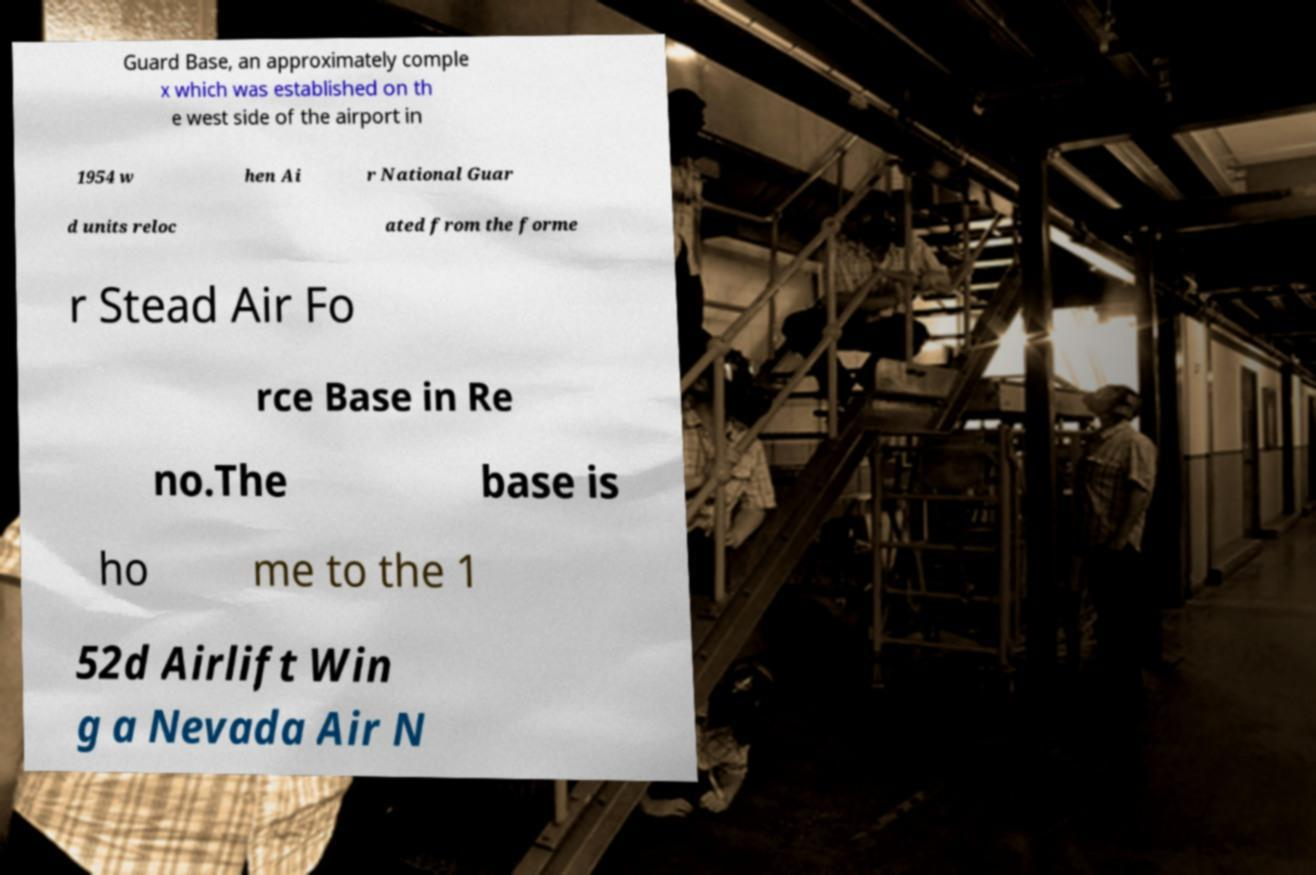Could you assist in decoding the text presented in this image and type it out clearly? Guard Base, an approximately comple x which was established on th e west side of the airport in 1954 w hen Ai r National Guar d units reloc ated from the forme r Stead Air Fo rce Base in Re no.The base is ho me to the 1 52d Airlift Win g a Nevada Air N 